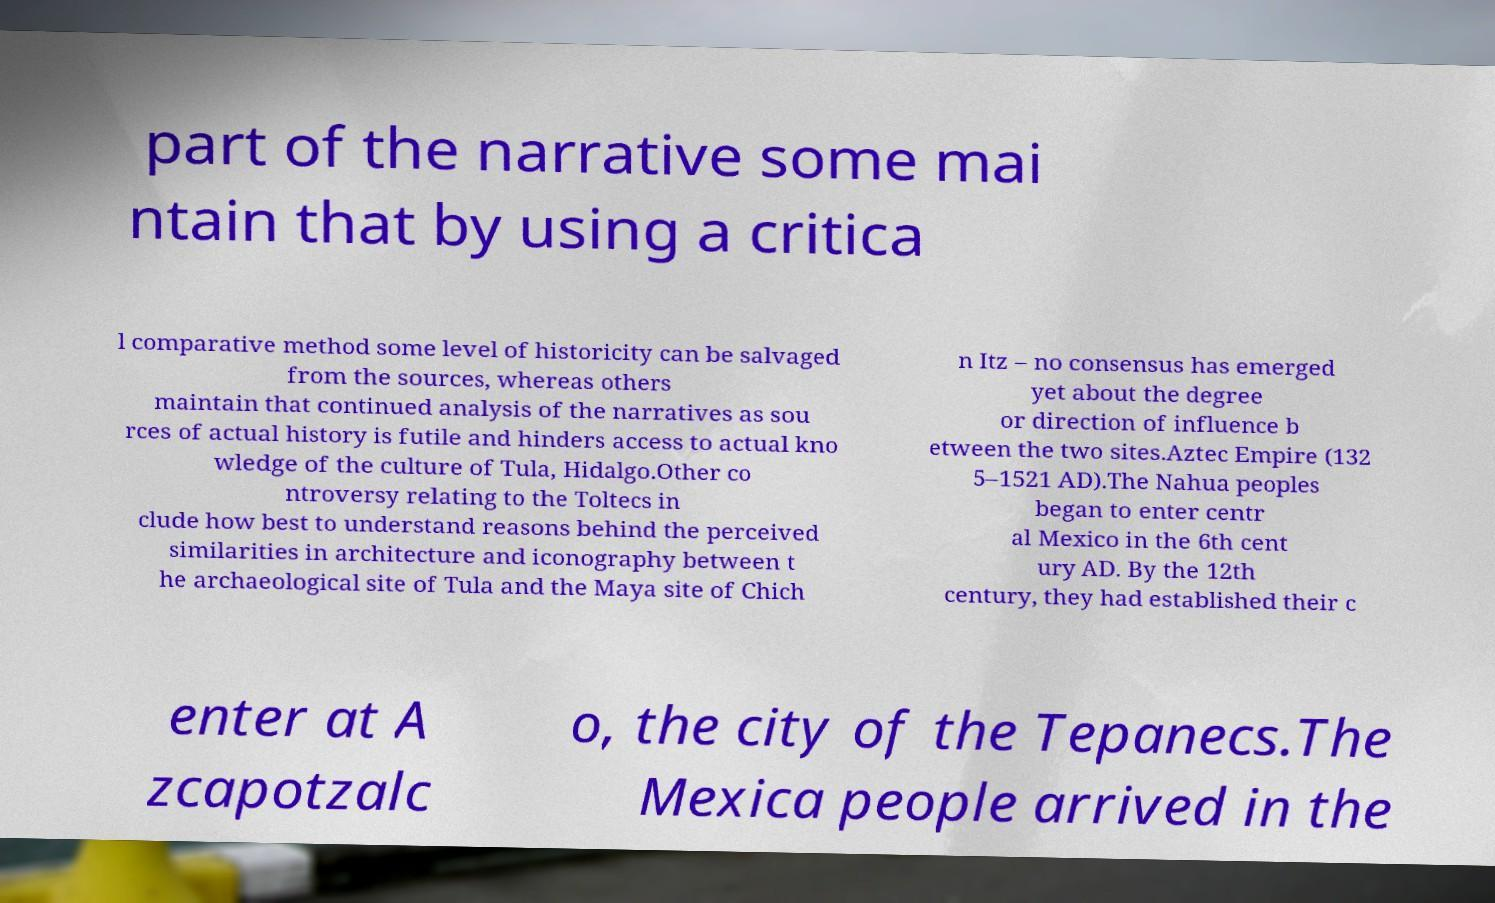What messages or text are displayed in this image? I need them in a readable, typed format. part of the narrative some mai ntain that by using a critica l comparative method some level of historicity can be salvaged from the sources, whereas others maintain that continued analysis of the narratives as sou rces of actual history is futile and hinders access to actual kno wledge of the culture of Tula, Hidalgo.Other co ntroversy relating to the Toltecs in clude how best to understand reasons behind the perceived similarities in architecture and iconography between t he archaeological site of Tula and the Maya site of Chich n Itz – no consensus has emerged yet about the degree or direction of influence b etween the two sites.Aztec Empire (132 5–1521 AD).The Nahua peoples began to enter centr al Mexico in the 6th cent ury AD. By the 12th century, they had established their c enter at A zcapotzalc o, the city of the Tepanecs.The Mexica people arrived in the 